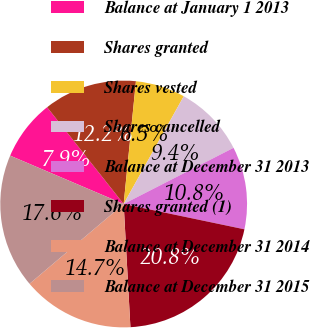Convert chart to OTSL. <chart><loc_0><loc_0><loc_500><loc_500><pie_chart><fcel>Balance at January 1 2013<fcel>Shares granted<fcel>Shares vested<fcel>Shares cancelled<fcel>Balance at December 31 2013<fcel>Shares granted (1)<fcel>Balance at December 31 2014<fcel>Balance at December 31 2015<nl><fcel>7.94%<fcel>12.24%<fcel>6.51%<fcel>9.38%<fcel>10.81%<fcel>20.84%<fcel>14.68%<fcel>17.6%<nl></chart> 